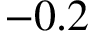Convert formula to latex. <formula><loc_0><loc_0><loc_500><loc_500>- 0 . 2</formula> 